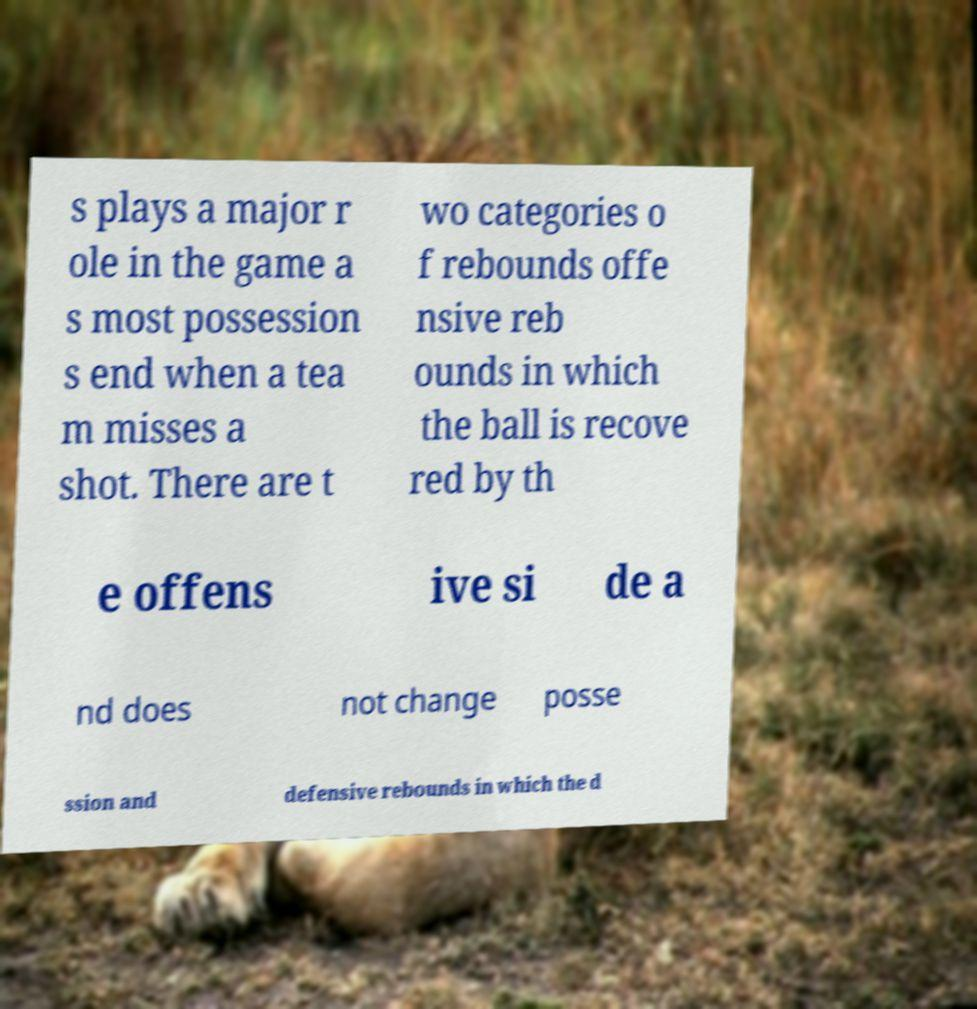Can you accurately transcribe the text from the provided image for me? s plays a major r ole in the game a s most possession s end when a tea m misses a shot. There are t wo categories o f rebounds offe nsive reb ounds in which the ball is recove red by th e offens ive si de a nd does not change posse ssion and defensive rebounds in which the d 